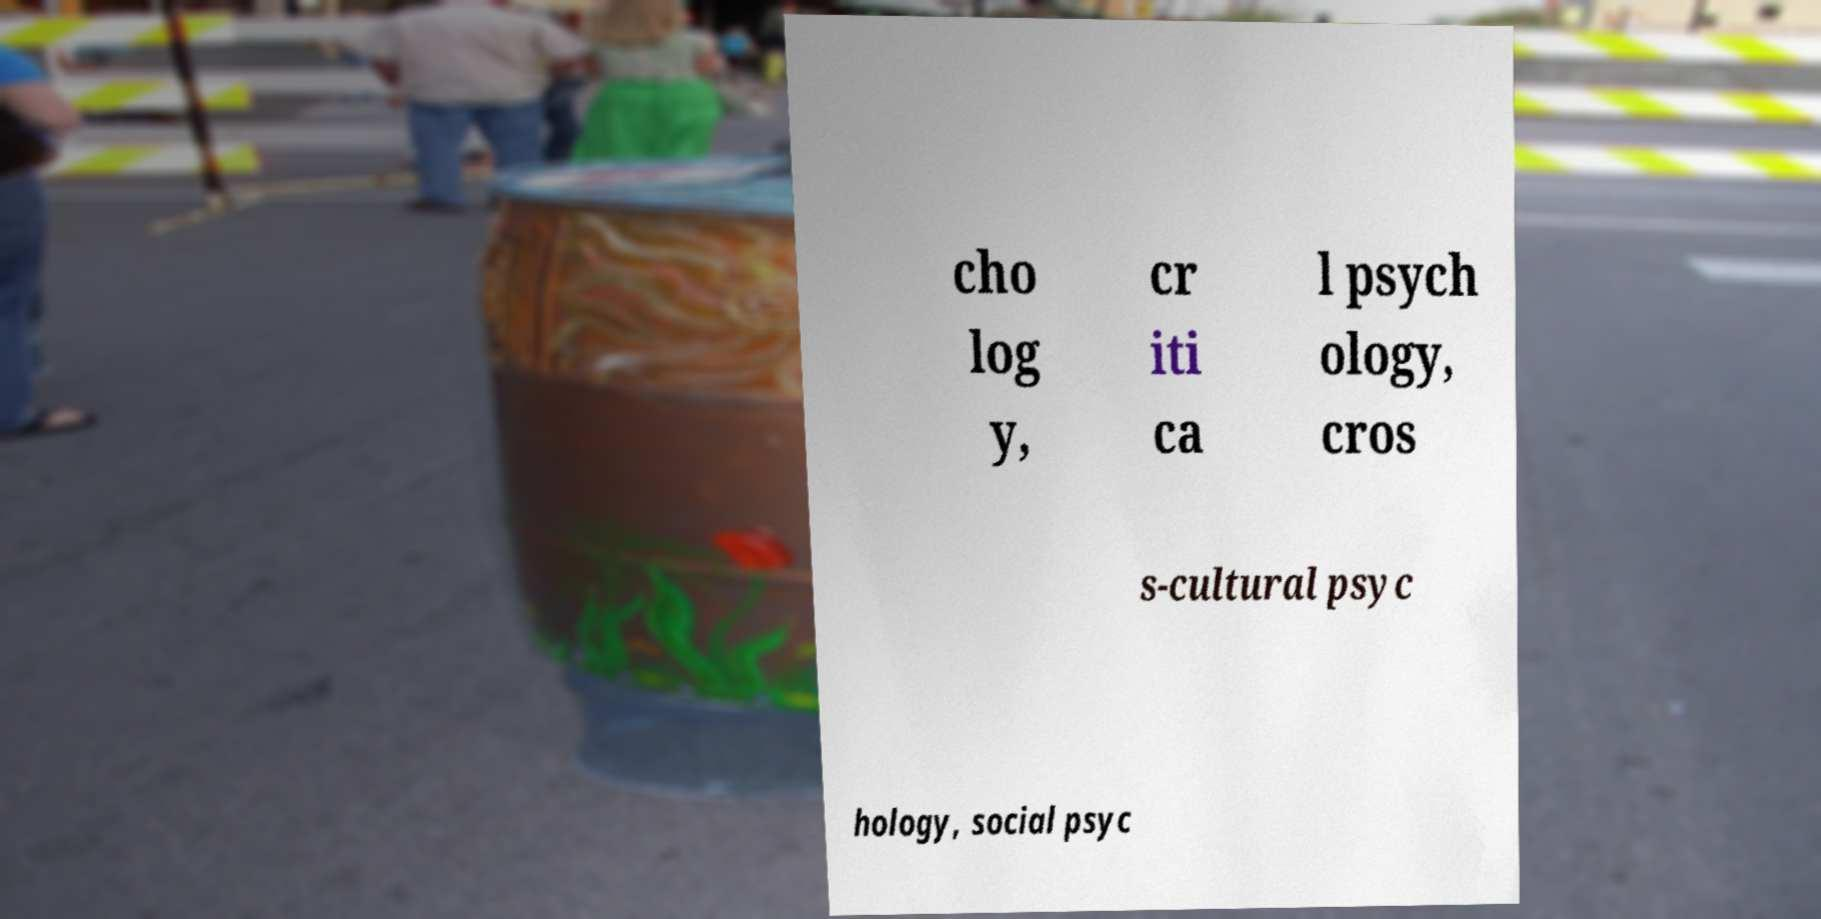Could you assist in decoding the text presented in this image and type it out clearly? cho log y, cr iti ca l psych ology, cros s-cultural psyc hology, social psyc 